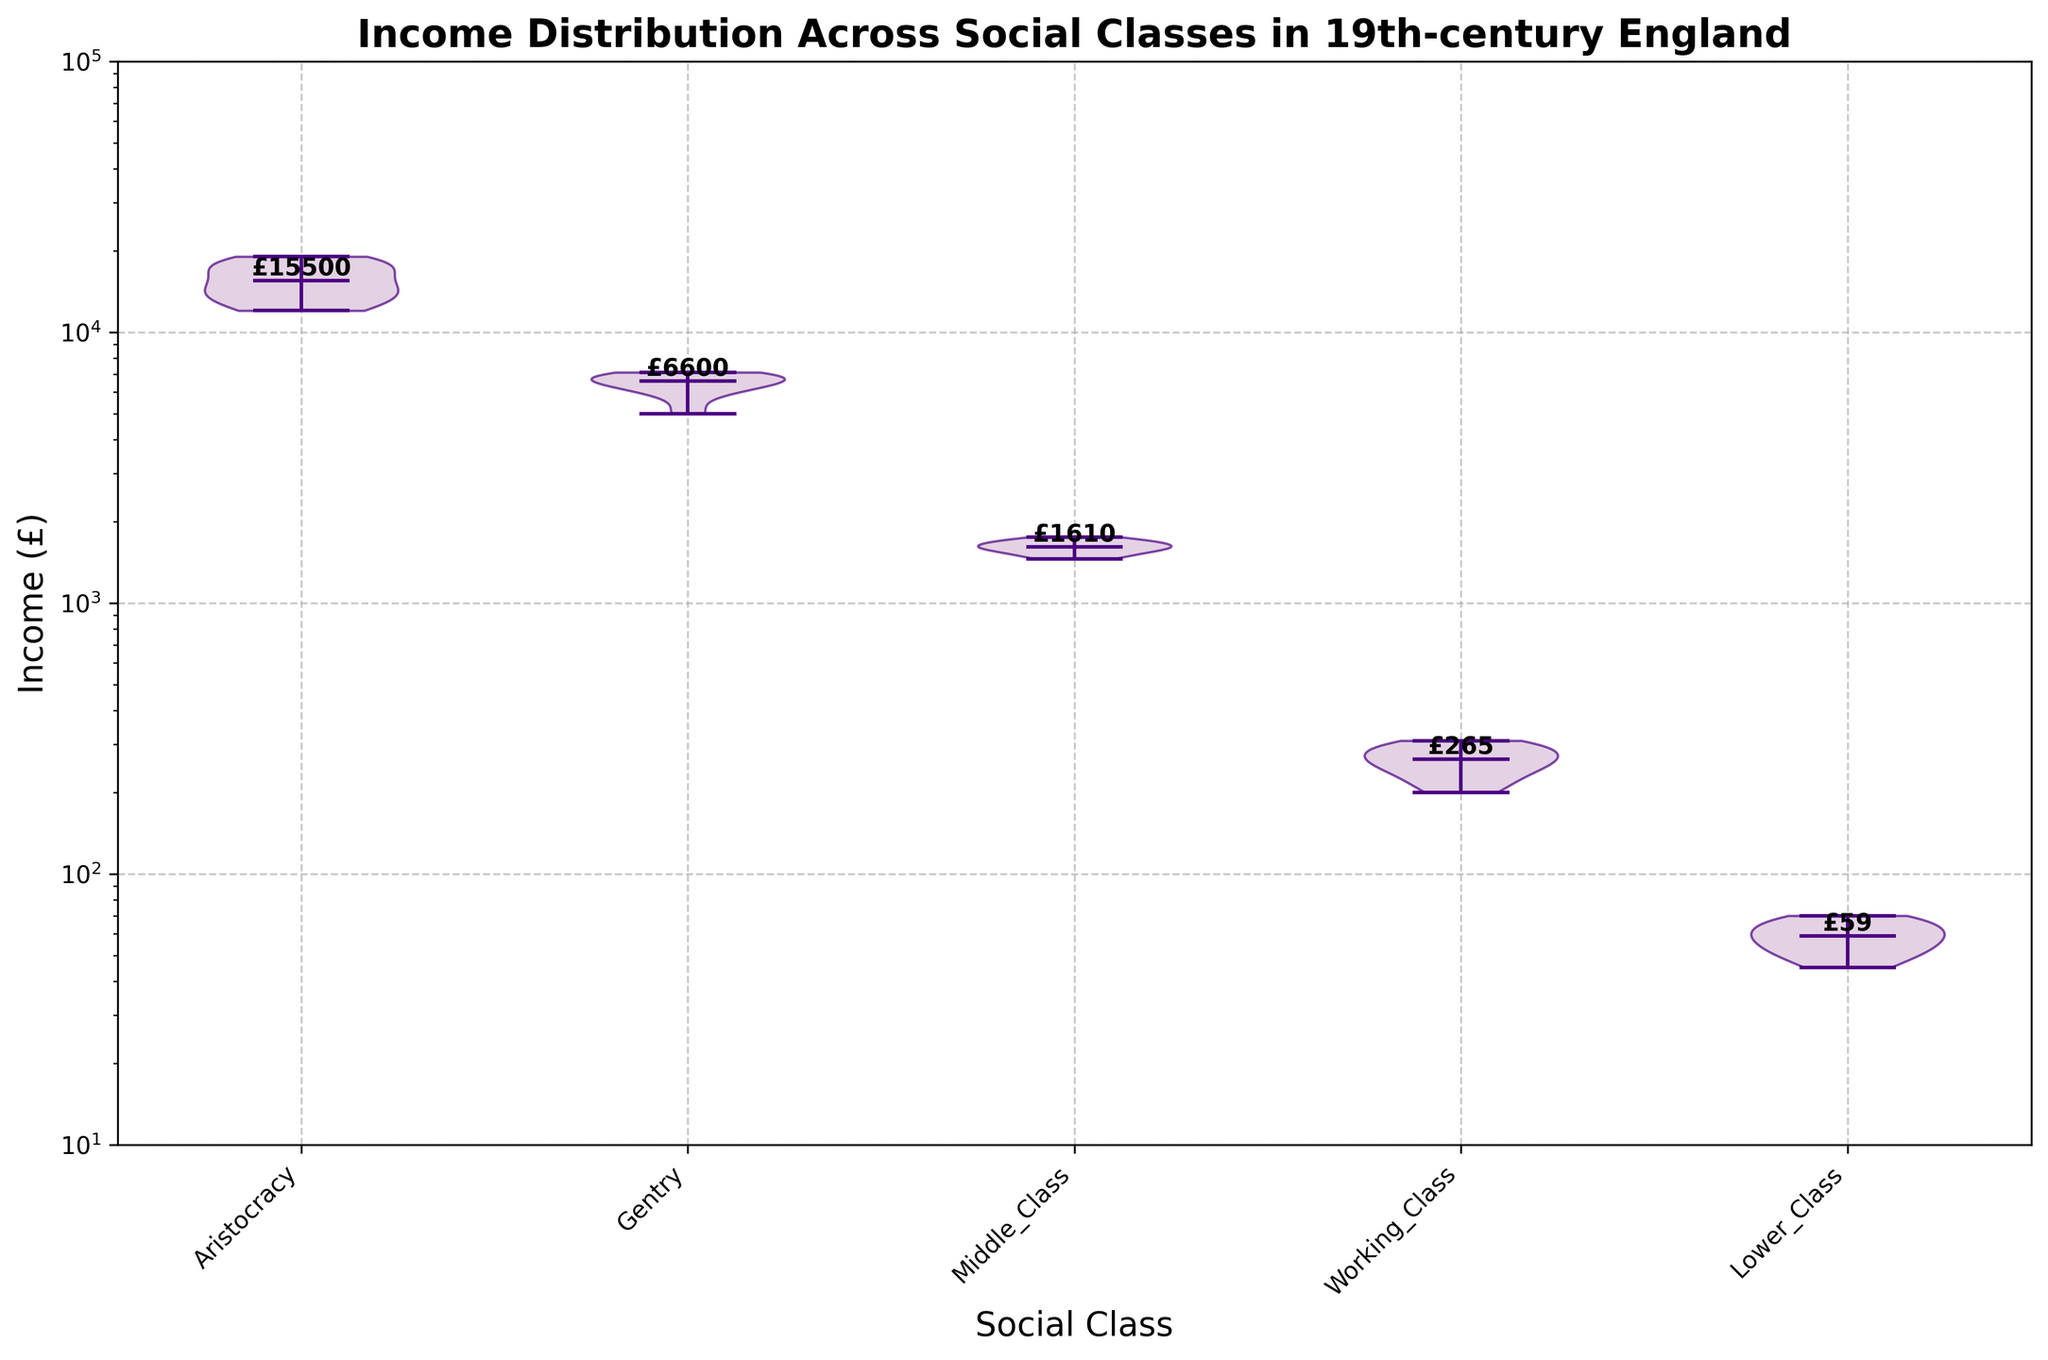What's the title of the figure? The title of the figure is directly displayed at the top.
Answer: Income Distribution Across Social Classes in 19th-century England What are the five social classes represented in the figure? By examining the x-axis labels, we can see the names of the social classes.
Answer: Aristocracy, Gentry, Middle Class, Working Class, Lower Class Which social class has the highest income distribution range? We observe the spread of the violin plots; the range is the widest for the Aristocracy.
Answer: Aristocracy What is the approximate median income for the Middle Class? The violin plot has a horizontal line inside each shape representing the median; for the Middle Class, this line is around 1600.
Answer: £1600 Is the income distribution for the Lower Class wider or narrower compared to the Working Class? The width of the violin plots indicates the distribution; the Lower Class plot is narrower compared to the Working Class.
Answer: Narrower Which social class has the lowest median income? Looking at the horizontal median lines in the violin plots, the Lower Class clearly has the lowest median income.
Answer: Lower Class How does the income range of the Gentry compare to the Aristocracy? The Gentry has a smaller and more condensed range compared to the relatively wider and higher range of the Aristocracy.
Answer: Smaller and more condensed What can you deduce about the income distribution of the Working Class compared to the Gentry from the violin plot shape? The violin plot for the Working Class is much narrower and more symmetric, indicating a smaller range and less variance in income compared to the Gentry.
Answer: Smaller range and less variance Why is the income distribution displayed on a logarithmic scale? The logarithmic y-axis helps manage the wide range of incomes, spreading the values in a non-linear manner to better visualize differences between groups.
Answer: To better visualize differences in a wide income range 